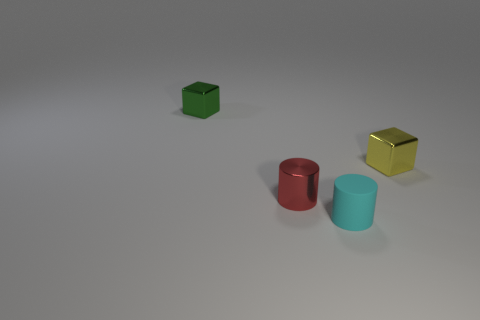Is the tiny cube on the left side of the small red metallic cylinder made of the same material as the cube on the right side of the tiny green shiny object?
Give a very brief answer. Yes. What number of things are yellow metal objects or small things that are on the left side of the tiny cyan cylinder?
Ensure brevity in your answer.  3. Is there a small red metal object that has the same shape as the small cyan object?
Make the answer very short. Yes. What size is the object behind the tiny block in front of the metal cube left of the tiny yellow thing?
Ensure brevity in your answer.  Small. Are there an equal number of small yellow blocks on the right side of the tiny green thing and small green metallic cubes that are behind the tiny rubber cylinder?
Offer a very short reply. Yes. What is the size of the green block that is the same material as the tiny red object?
Keep it short and to the point. Small. The tiny rubber object is what color?
Keep it short and to the point. Cyan. What number of matte cylinders are the same color as the shiny cylinder?
Keep it short and to the point. 0. What is the material of the cyan object that is the same size as the green cube?
Your answer should be very brief. Rubber. There is a tiny cylinder in front of the tiny red metallic object; is there a tiny metallic cylinder that is left of it?
Make the answer very short. Yes. 